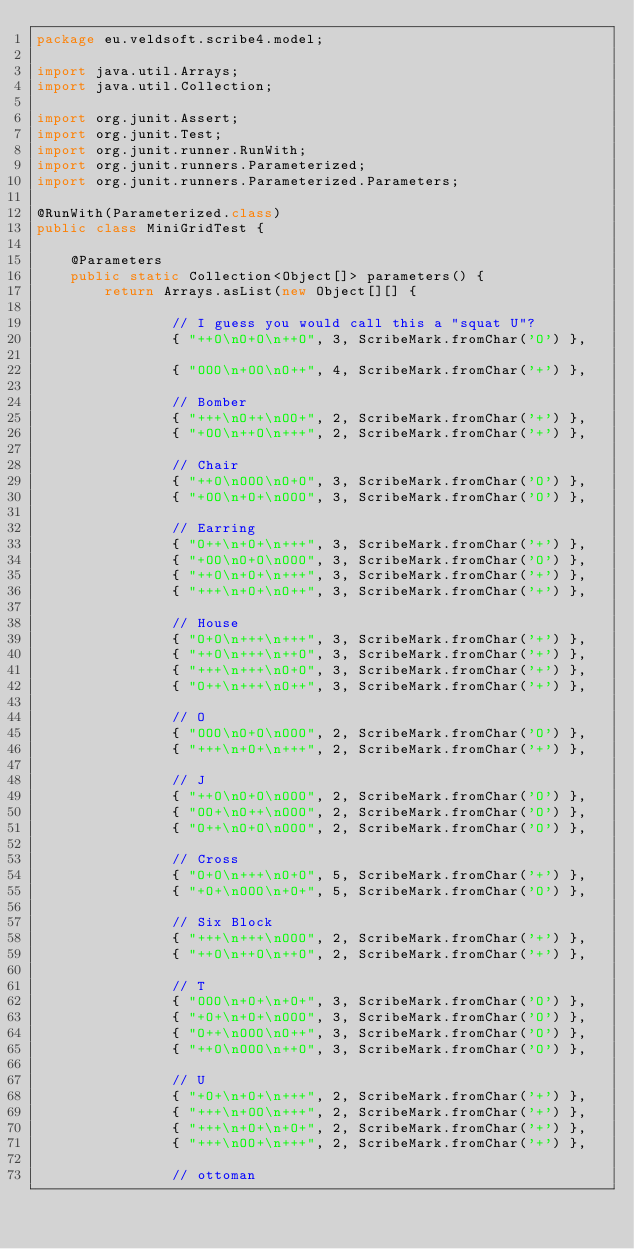<code> <loc_0><loc_0><loc_500><loc_500><_Java_>package eu.veldsoft.scribe4.model;

import java.util.Arrays;
import java.util.Collection;

import org.junit.Assert;
import org.junit.Test;
import org.junit.runner.RunWith;
import org.junit.runners.Parameterized;
import org.junit.runners.Parameterized.Parameters;

@RunWith(Parameterized.class)
public class MiniGridTest {

	@Parameters
	public static Collection<Object[]> parameters() {
		return Arrays.asList(new Object[][] {

				// I guess you would call this a "squat U"?
				{ "++O\nO+O\n++O", 3, ScribeMark.fromChar('O') },

				{ "OOO\n+OO\nO++", 4, ScribeMark.fromChar('+') },

				// Bomber
				{ "+++\nO++\nOO+", 2, ScribeMark.fromChar('+') },
				{ "+OO\n++O\n+++", 2, ScribeMark.fromChar('+') },

				// Chair
				{ "++O\nOOO\nO+O", 3, ScribeMark.fromChar('O') },
				{ "+OO\n+O+\nOOO", 3, ScribeMark.fromChar('O') },

				// Earring
				{ "O++\n+O+\n+++", 3, ScribeMark.fromChar('+') },
				{ "+OO\nO+O\nOOO", 3, ScribeMark.fromChar('O') },
				{ "++O\n+O+\n+++", 3, ScribeMark.fromChar('+') },
				{ "+++\n+O+\nO++", 3, ScribeMark.fromChar('+') },

				// House
				{ "O+O\n+++\n+++", 3, ScribeMark.fromChar('+') },
				{ "++O\n+++\n++O", 3, ScribeMark.fromChar('+') },
				{ "+++\n+++\nO+O", 3, ScribeMark.fromChar('+') },
				{ "O++\n+++\nO++", 3, ScribeMark.fromChar('+') },

				// O
				{ "OOO\nO+O\nOOO", 2, ScribeMark.fromChar('O') },
				{ "+++\n+O+\n+++", 2, ScribeMark.fromChar('+') },

				// J
				{ "++O\nO+O\nOOO", 2, ScribeMark.fromChar('O') },
				{ "OO+\nO++\nOOO", 2, ScribeMark.fromChar('O') },
				{ "O++\nO+O\nOOO", 2, ScribeMark.fromChar('O') },

				// Cross
				{ "O+O\n+++\nO+O", 5, ScribeMark.fromChar('+') },
				{ "+O+\nOOO\n+O+", 5, ScribeMark.fromChar('O') },

				// Six Block
				{ "+++\n+++\nOOO", 2, ScribeMark.fromChar('+') },
				{ "++O\n++O\n++O", 2, ScribeMark.fromChar('+') },

				// T
				{ "OOO\n+O+\n+O+", 3, ScribeMark.fromChar('O') },
				{ "+O+\n+O+\nOOO", 3, ScribeMark.fromChar('O') },
				{ "O++\nOOO\nO++", 3, ScribeMark.fromChar('O') },
				{ "++O\nOOO\n++O", 3, ScribeMark.fromChar('O') },

				// U
				{ "+O+\n+O+\n+++", 2, ScribeMark.fromChar('+') },
				{ "+++\n+OO\n+++", 2, ScribeMark.fromChar('+') },
				{ "+++\n+O+\n+O+", 2, ScribeMark.fromChar('+') },
				{ "+++\nOO+\n+++", 2, ScribeMark.fromChar('+') },

				// ottoman</code> 